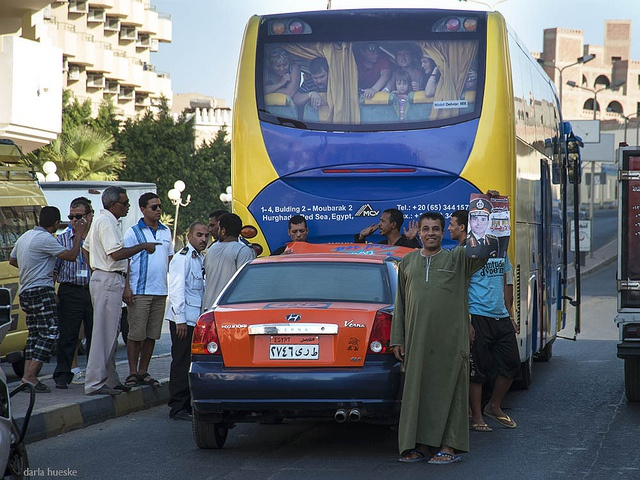Describe the objects in this image and their specific colors. I can see bus in gray, navy, and blue tones, car in gray, black, navy, and brown tones, people in gray and black tones, people in gray, black, and lightblue tones, and people in gray, darkgray, and black tones in this image. 